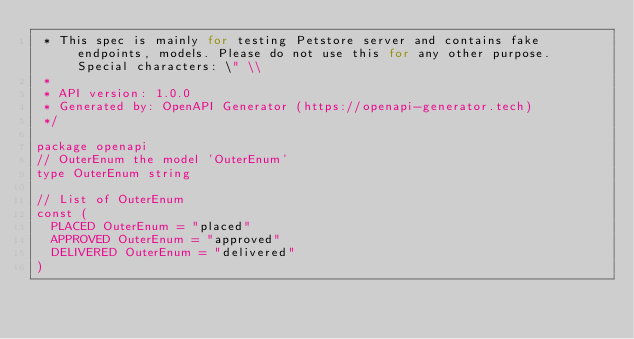Convert code to text. <code><loc_0><loc_0><loc_500><loc_500><_Go_> * This spec is mainly for testing Petstore server and contains fake endpoints, models. Please do not use this for any other purpose. Special characters: \" \\
 *
 * API version: 1.0.0
 * Generated by: OpenAPI Generator (https://openapi-generator.tech)
 */

package openapi
// OuterEnum the model 'OuterEnum'
type OuterEnum string

// List of OuterEnum
const (
	PLACED OuterEnum = "placed"
	APPROVED OuterEnum = "approved"
	DELIVERED OuterEnum = "delivered"
)


</code> 